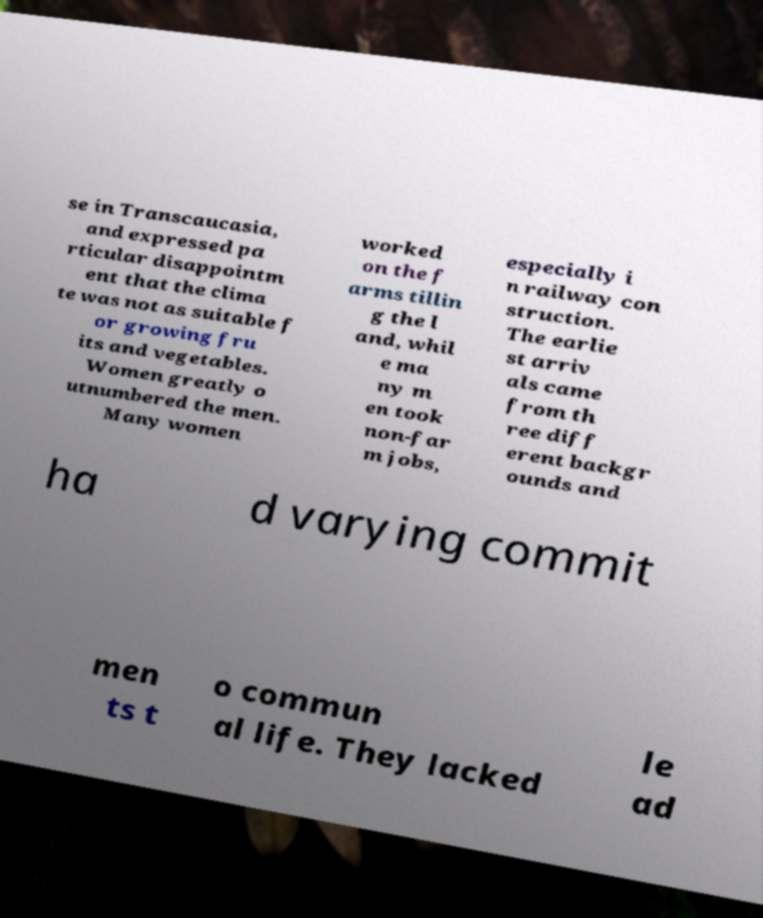For documentation purposes, I need the text within this image transcribed. Could you provide that? se in Transcaucasia, and expressed pa rticular disappointm ent that the clima te was not as suitable f or growing fru its and vegetables. Women greatly o utnumbered the men. Many women worked on the f arms tillin g the l and, whil e ma ny m en took non-far m jobs, especially i n railway con struction. The earlie st arriv als came from th ree diff erent backgr ounds and ha d varying commit men ts t o commun al life. They lacked le ad 